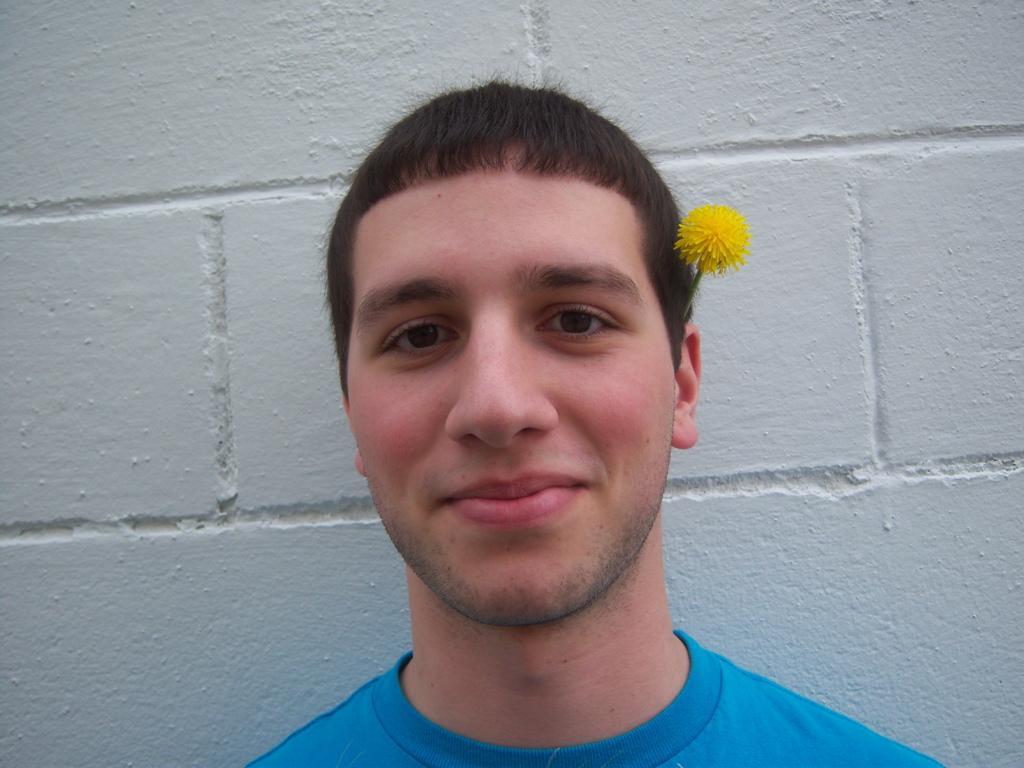Describe this image in one or two sentences. In the image there is a man smiling. And there is a flower on his ear. Behind him there is a wall. 